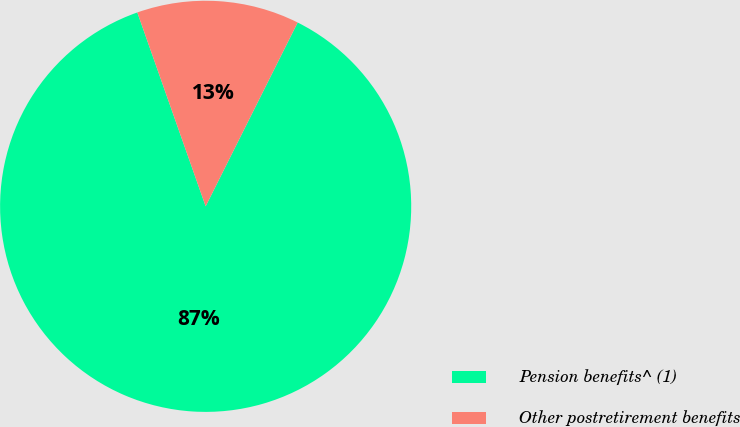Convert chart. <chart><loc_0><loc_0><loc_500><loc_500><pie_chart><fcel>Pension benefits^ (1)<fcel>Other postretirement benefits<nl><fcel>87.22%<fcel>12.78%<nl></chart> 